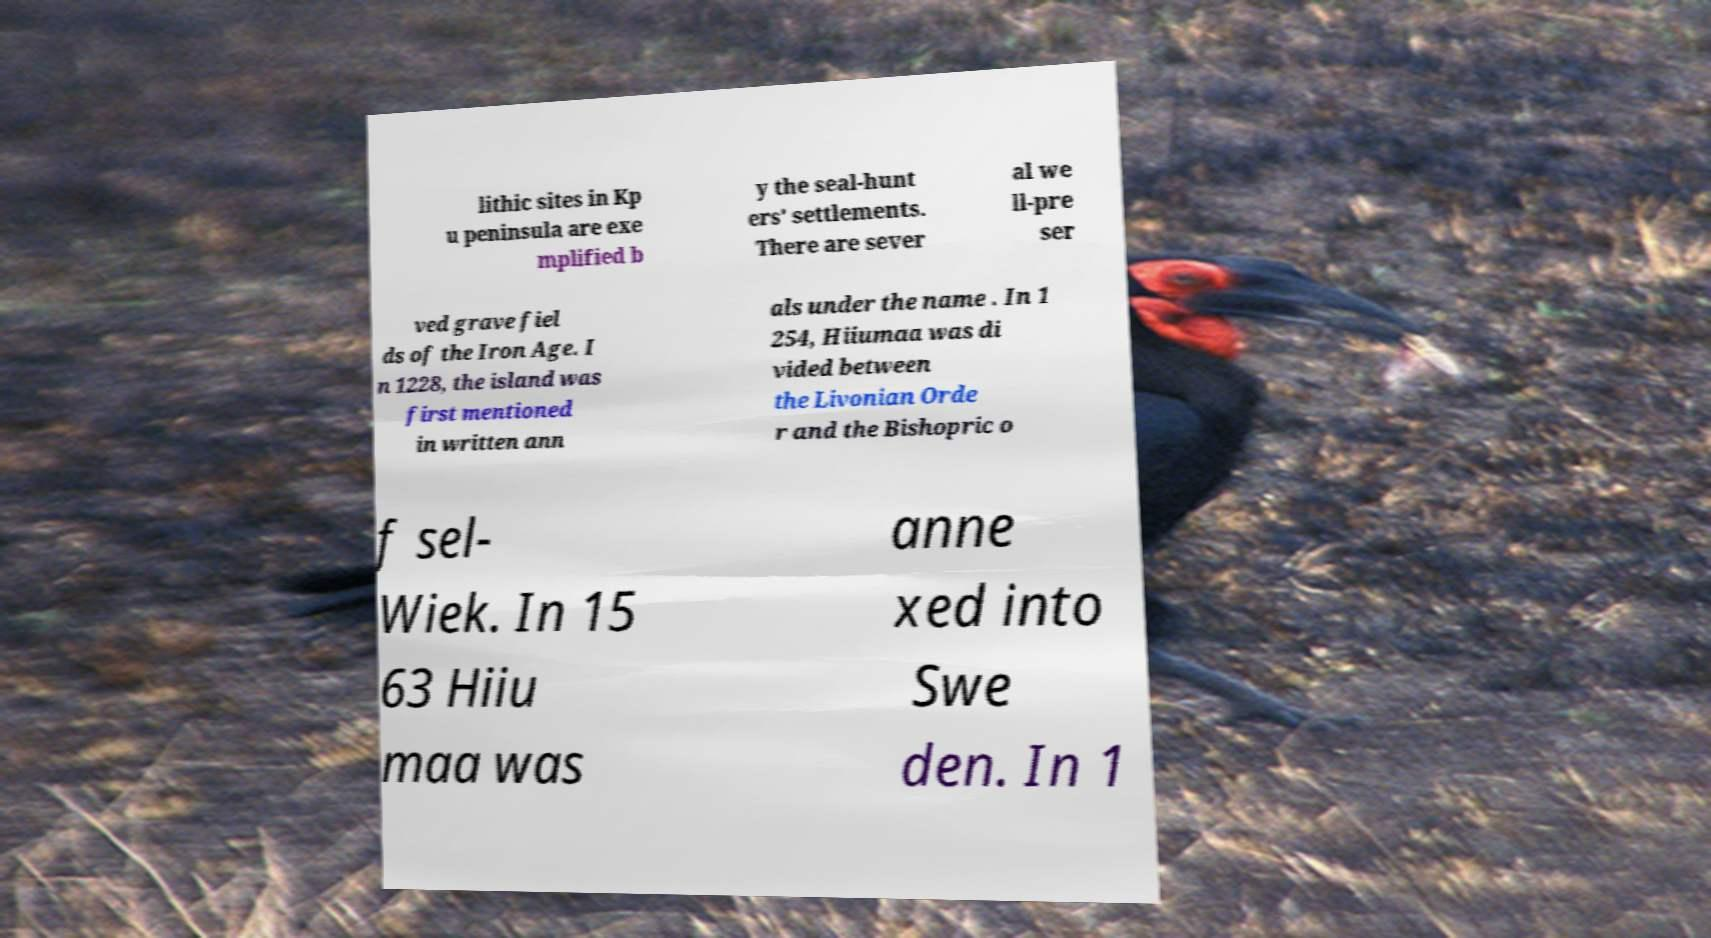Could you extract and type out the text from this image? lithic sites in Kp u peninsula are exe mplified b y the seal-hunt ers' settlements. There are sever al we ll-pre ser ved grave fiel ds of the Iron Age. I n 1228, the island was first mentioned in written ann als under the name . In 1 254, Hiiumaa was di vided between the Livonian Orde r and the Bishopric o f sel- Wiek. In 15 63 Hiiu maa was anne xed into Swe den. In 1 